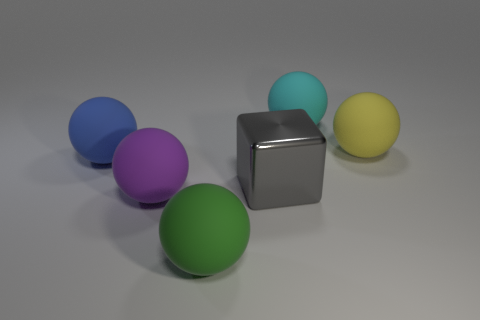What color is the matte thing right of the matte sphere behind the big rubber sphere to the right of the big cyan object? yellow 